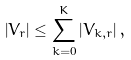<formula> <loc_0><loc_0><loc_500><loc_500>\left | V _ { r } \right | \leq \sum _ { k = 0 } ^ { K } \left | V _ { k , r } \right | ,</formula> 